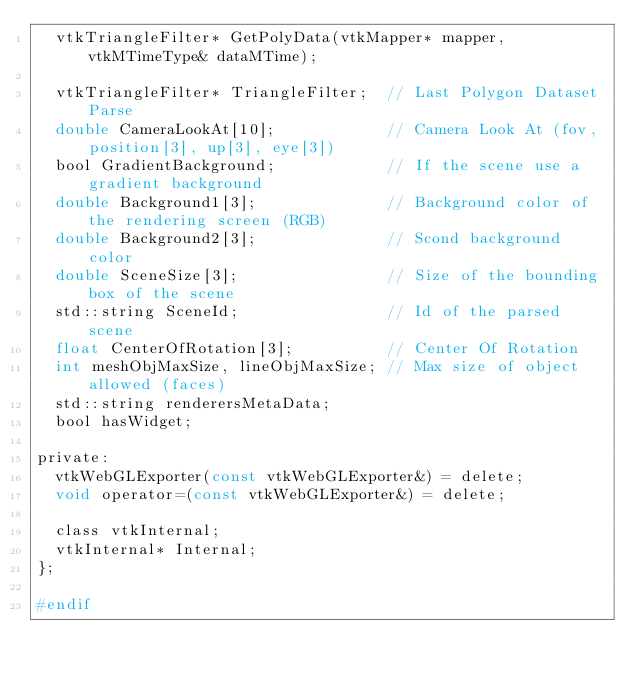<code> <loc_0><loc_0><loc_500><loc_500><_C_>  vtkTriangleFilter* GetPolyData(vtkMapper* mapper, vtkMTimeType& dataMTime);

  vtkTriangleFilter* TriangleFilter;  // Last Polygon Dataset Parse
  double CameraLookAt[10];            // Camera Look At (fov, position[3], up[3], eye[3])
  bool GradientBackground;            // If the scene use a gradient background
  double Background1[3];              // Background color of the rendering screen (RGB)
  double Background2[3];              // Scond background color
  double SceneSize[3];                // Size of the bounding box of the scene
  std::string SceneId;                // Id of the parsed scene
  float CenterOfRotation[3];          // Center Of Rotation
  int meshObjMaxSize, lineObjMaxSize; // Max size of object allowed (faces)
  std::string renderersMetaData;
  bool hasWidget;

private:
  vtkWebGLExporter(const vtkWebGLExporter&) = delete;
  void operator=(const vtkWebGLExporter&) = delete;

  class vtkInternal;
  vtkInternal* Internal;
};

#endif
</code> 